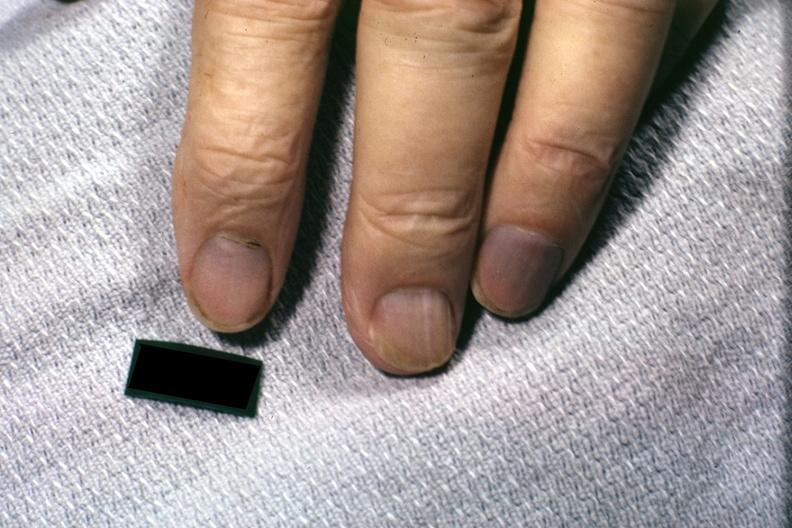what are present?
Answer the question using a single word or phrase. Extremities 